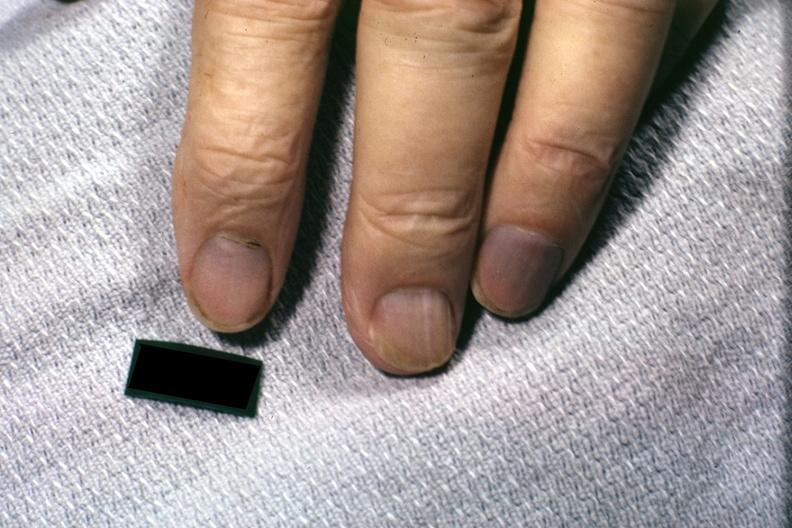what are present?
Answer the question using a single word or phrase. Extremities 